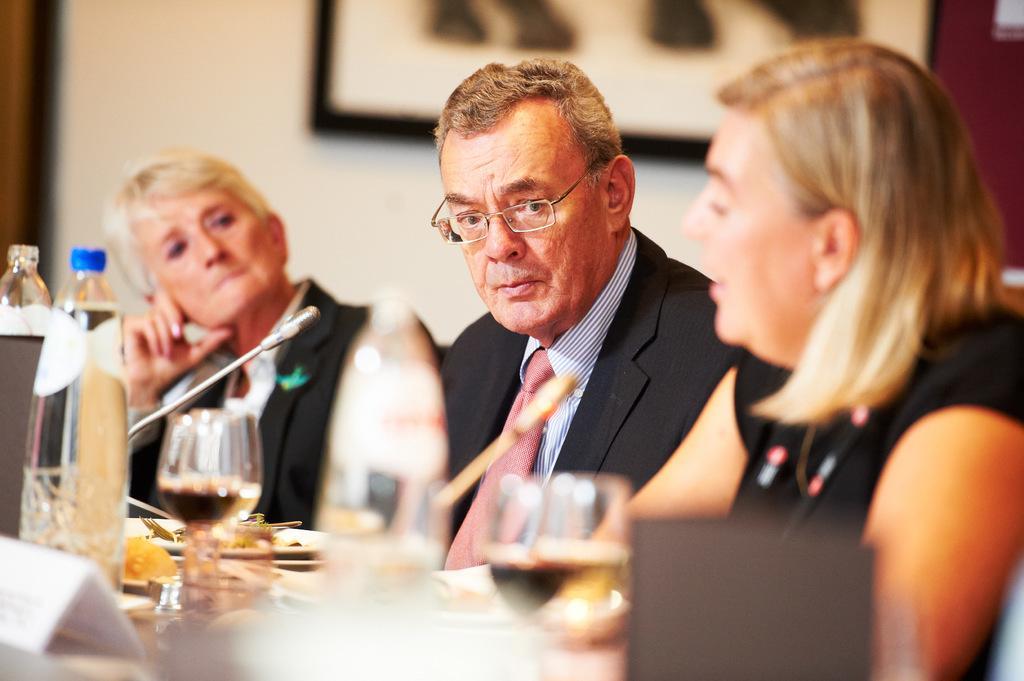Describe this image in one or two sentences. In this image we can see few people. There are many objects on the table. There is a photo on the wall. There is a microphone in the image. 